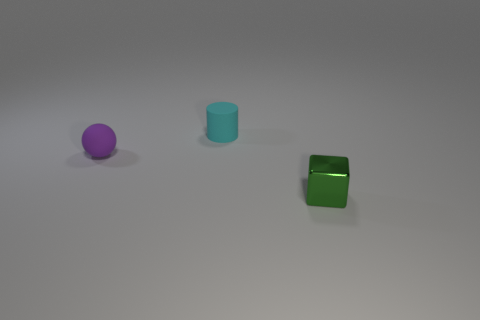How many shiny things have the same color as the tiny cube?
Your answer should be very brief. 0. Do the rubber object on the right side of the small purple rubber object and the small metal thing have the same shape?
Keep it short and to the point. No. The rubber thing in front of the matte thing right of the rubber object that is to the left of the rubber cylinder is what shape?
Give a very brief answer. Sphere. How big is the cyan cylinder?
Provide a short and direct response. Small. What is the color of the tiny thing that is the same material as the cylinder?
Keep it short and to the point. Purple. How many tiny objects are made of the same material as the purple ball?
Give a very brief answer. 1. Does the cylinder have the same color as the small matte thing left of the small cyan matte cylinder?
Give a very brief answer. No. What color is the tiny object that is behind the tiny thing that is on the left side of the cyan rubber object?
Provide a succinct answer. Cyan. There is a matte cylinder that is the same size as the purple rubber ball; what is its color?
Provide a short and direct response. Cyan. Is there another big cyan object that has the same shape as the cyan rubber object?
Your answer should be very brief. No. 